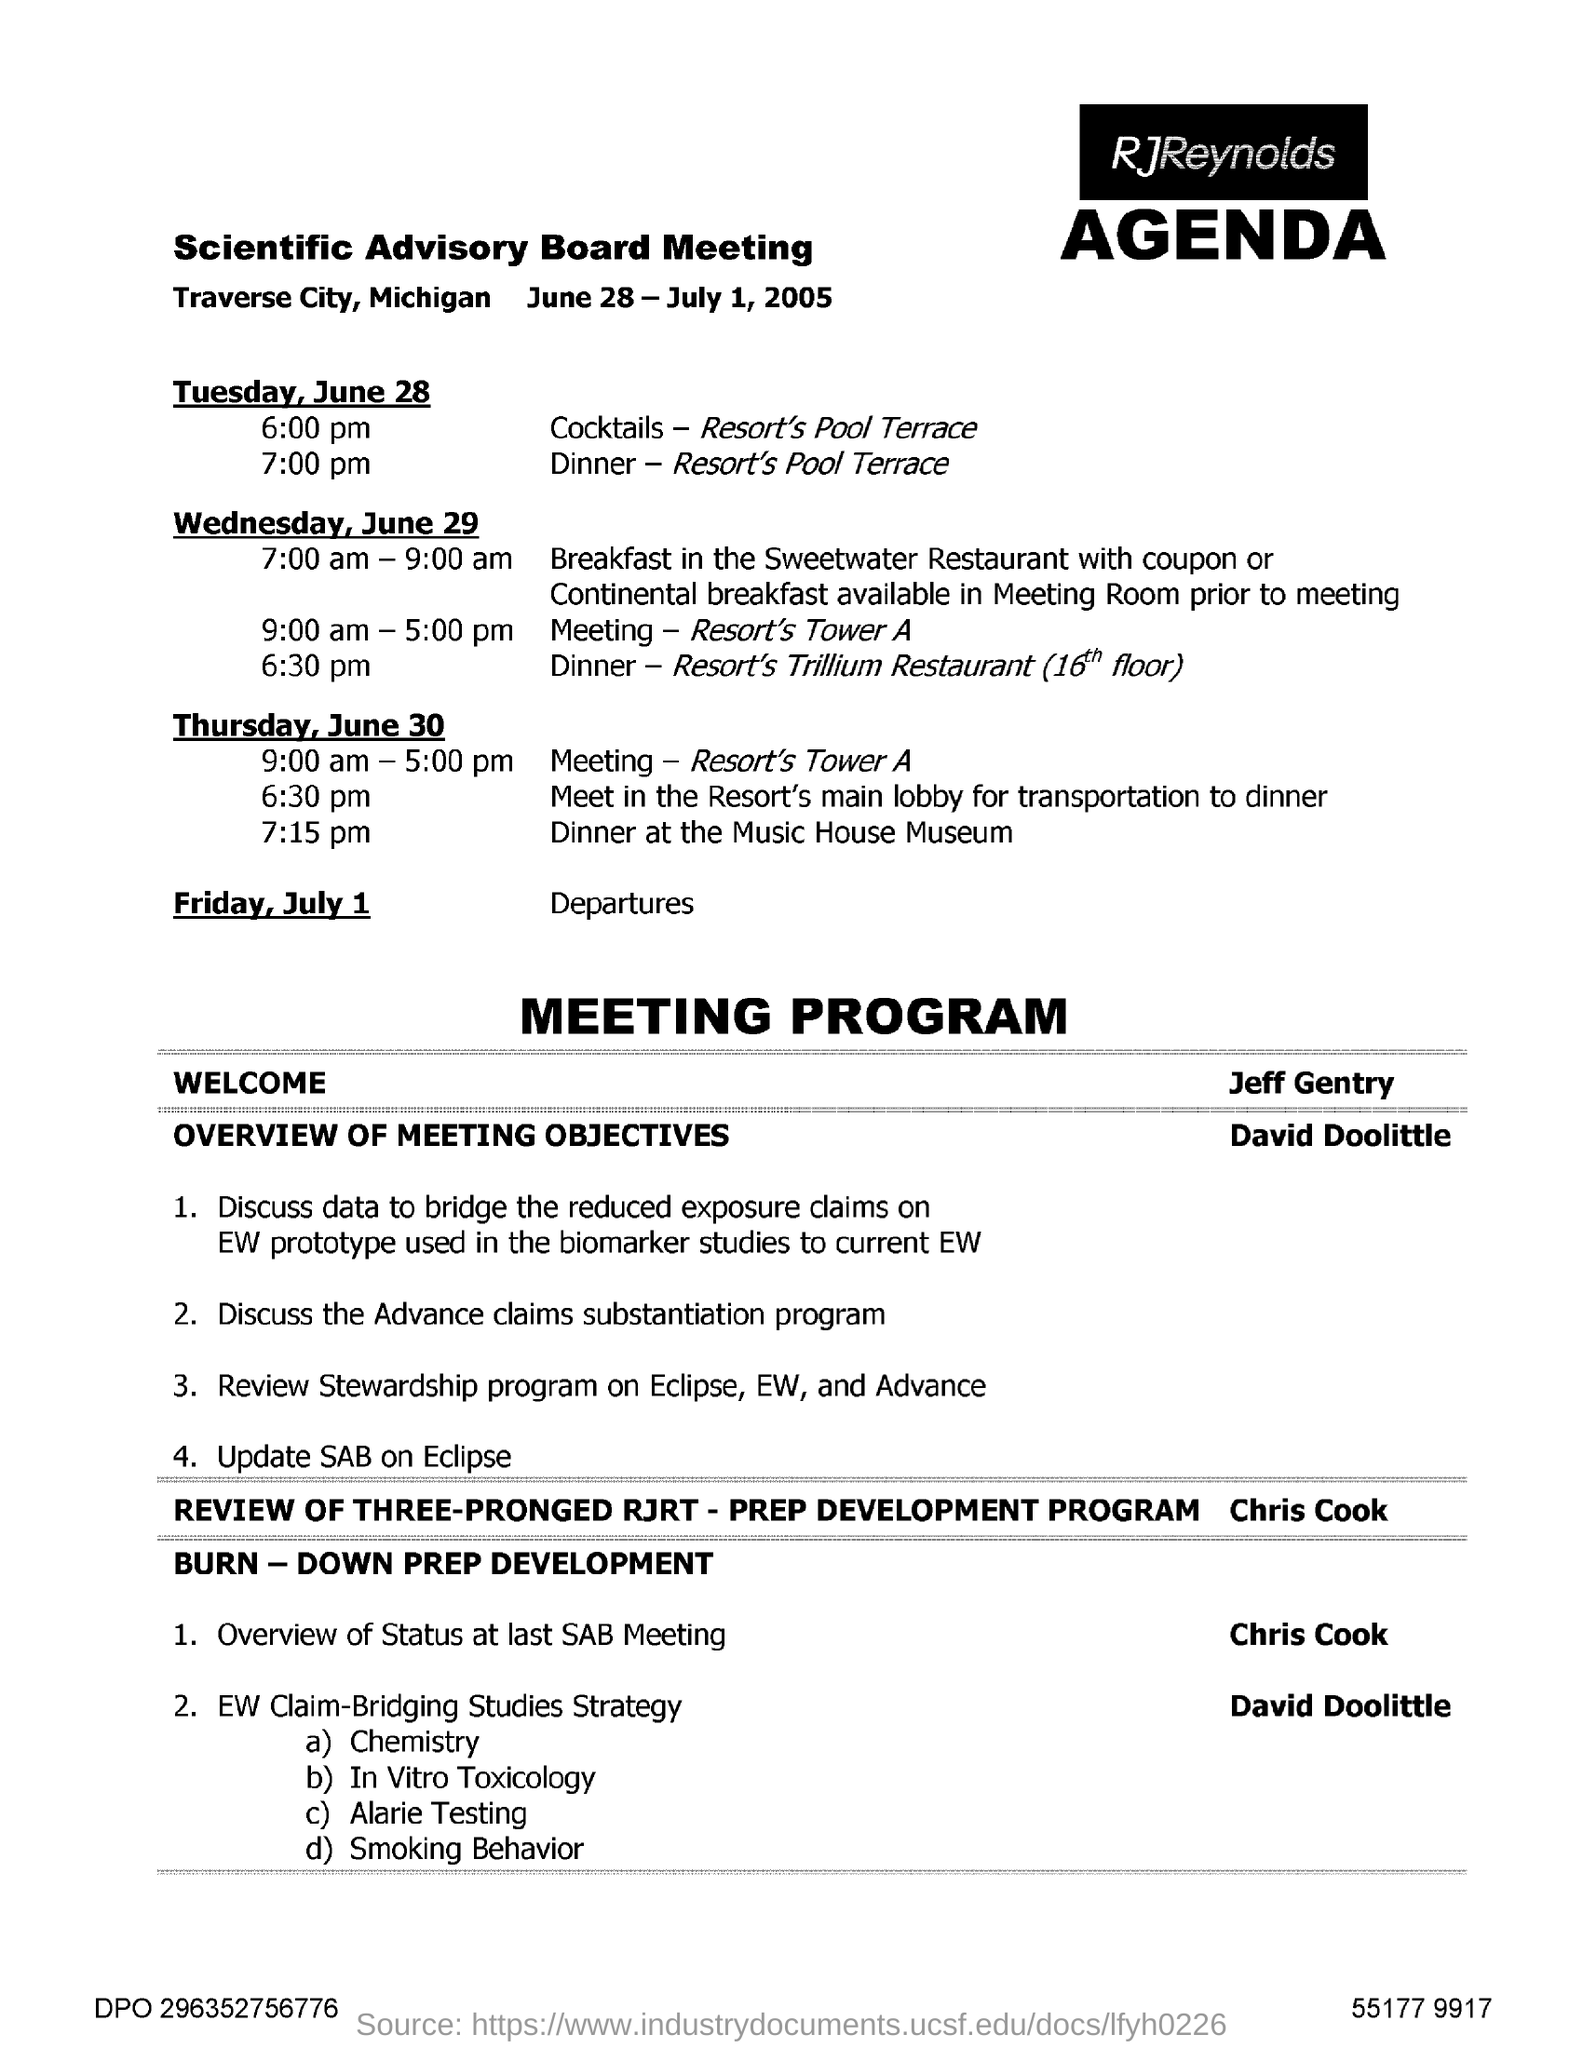List a handful of essential elements in this visual. The Scientific Advisory Board Meeting will take place on June 28 - July 1, 2005. The Scientific Advisory Board will be holding its meeting in Traverse City, Michigan. 